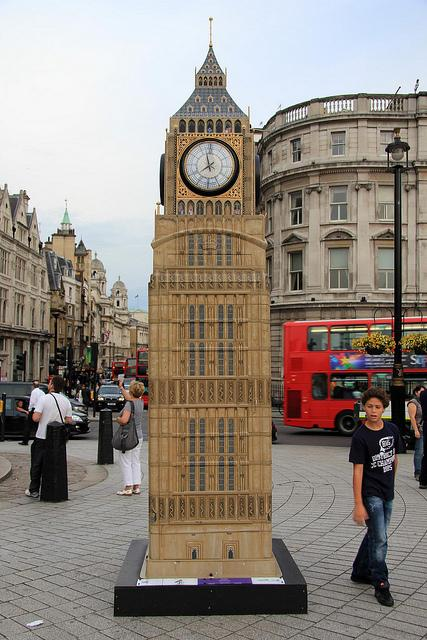What is actually the tallest object in the picture?

Choices:
A) boy
B) buildings
C) bus
D) clock tower buildings 